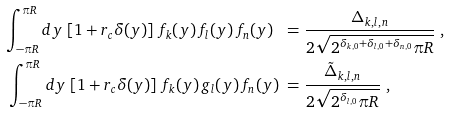Convert formula to latex. <formula><loc_0><loc_0><loc_500><loc_500>\int _ { - \pi R } ^ { \pi R } d y \, \left [ 1 + r _ { c } \delta ( y ) \right ] \, f _ { k } ( y ) \, f _ { l } ( y ) \, f _ { n } ( y ) \ = & \ \frac { \Delta _ { k , l , n } } { 2 \sqrt { 2 ^ { \delta _ { k , 0 } + \delta _ { l , 0 } + \delta _ { n , 0 } } \pi R } } \ , \\ \int _ { - \pi R } ^ { \pi R } d y \, \left [ 1 + r _ { c } \delta ( y ) \right ] \, f _ { k } ( y ) \, g _ { l } ( y ) \, f _ { n } ( y ) \ = & \ \frac { \tilde { \Delta } _ { k , l , n } } { 2 \sqrt { 2 ^ { \delta _ { l , 0 } } \pi R } } \ ,</formula> 